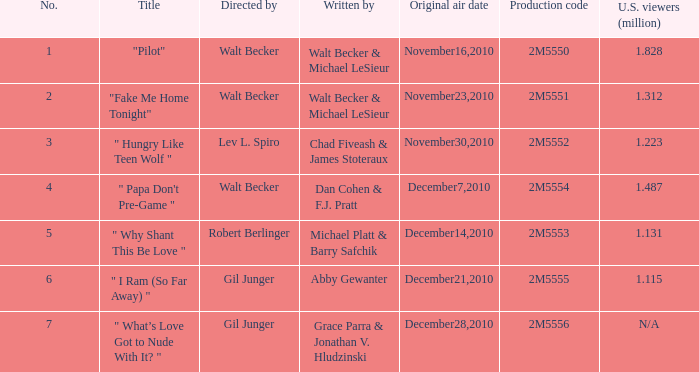What was the number of million viewers in the u.s. who watched "fake me home tonight"? 1.312. 